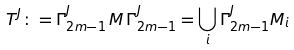Convert formula to latex. <formula><loc_0><loc_0><loc_500><loc_500>T ^ { J } \colon = \Gamma _ { 2 m - 1 } ^ { J } \, M \, \Gamma _ { 2 m - 1 } ^ { J } = \bigcup _ { i } \Gamma _ { 2 m - 1 } ^ { J } M _ { i }</formula> 